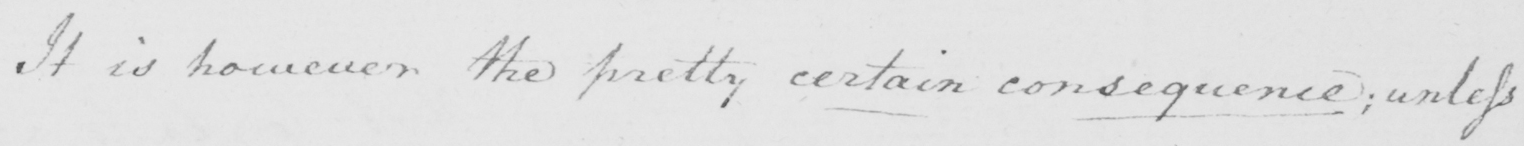Please transcribe the handwritten text in this image. It is however the pretty certain consequence  ; unless 